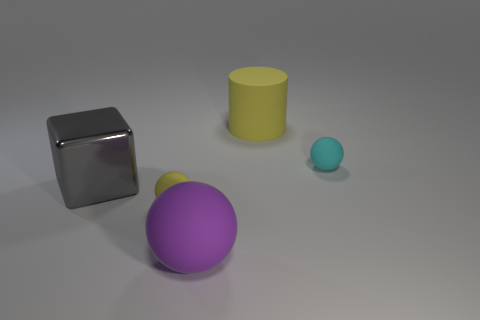Can you describe the lighting and shadows seen in the image? The lighting in the image appears to be soft and diffuse, likely coming from above as indicated by the gentle shadows that are cast directly under and to the opposite side of each object. These shadows help to enhance the three-dimensional appearance of the objects on the flat surface. 